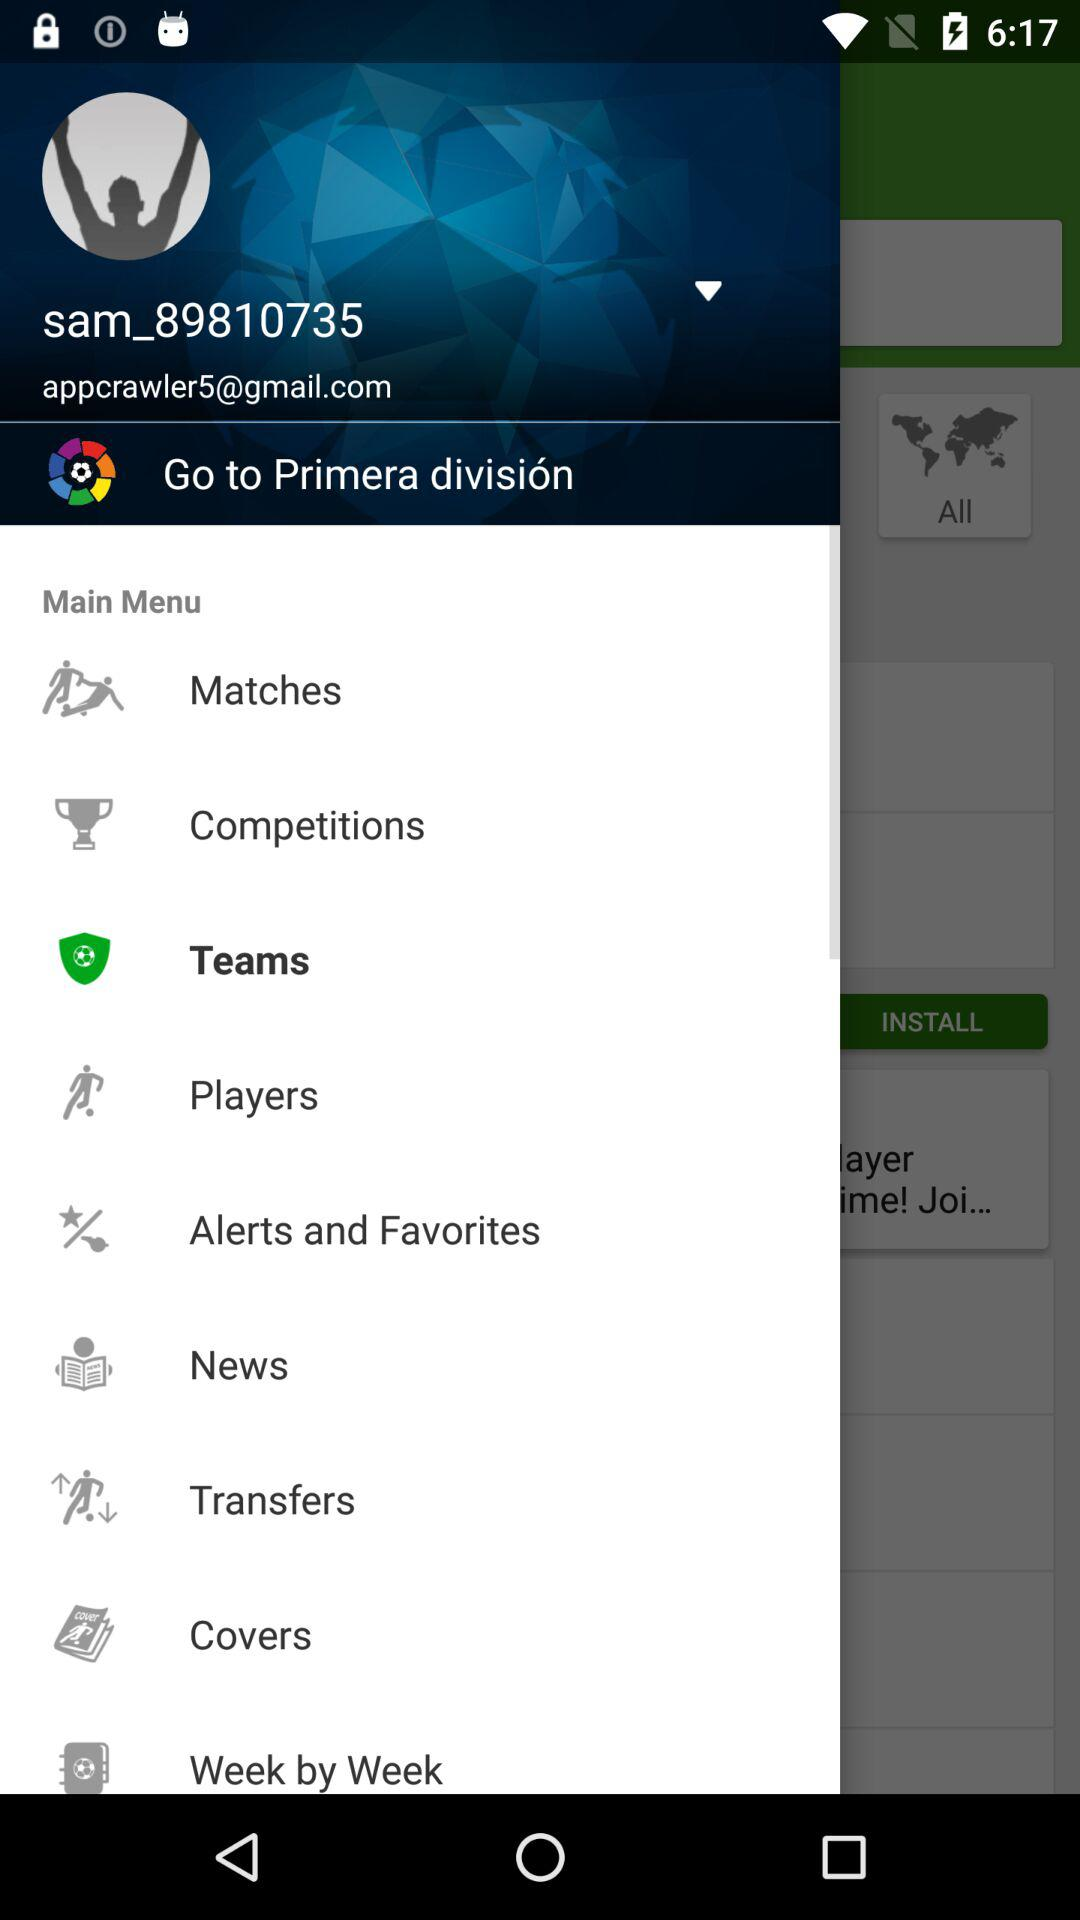What is the name of the user? The user name is sam_89810735. 